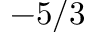Convert formula to latex. <formula><loc_0><loc_0><loc_500><loc_500>- 5 / 3</formula> 